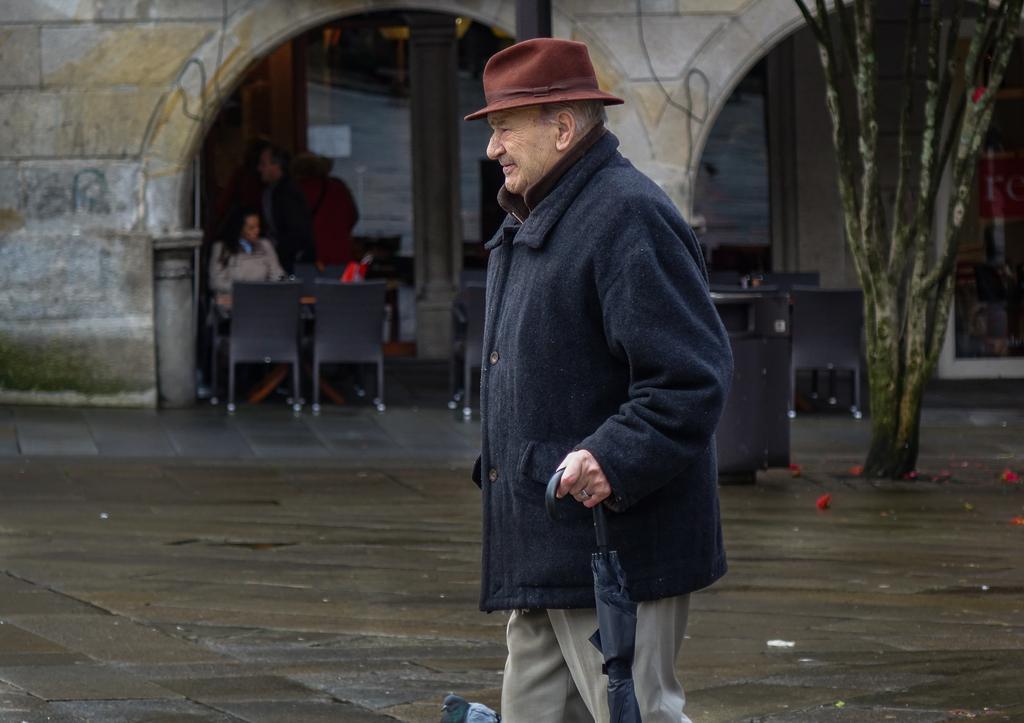Describe this image in one or two sentences. This picture shows a man standing and holding a umbrella in his hand and he wore a hat on his head and we see few people seated on the chair and we see a tree on the right side and we see a building and a bird on the floor 